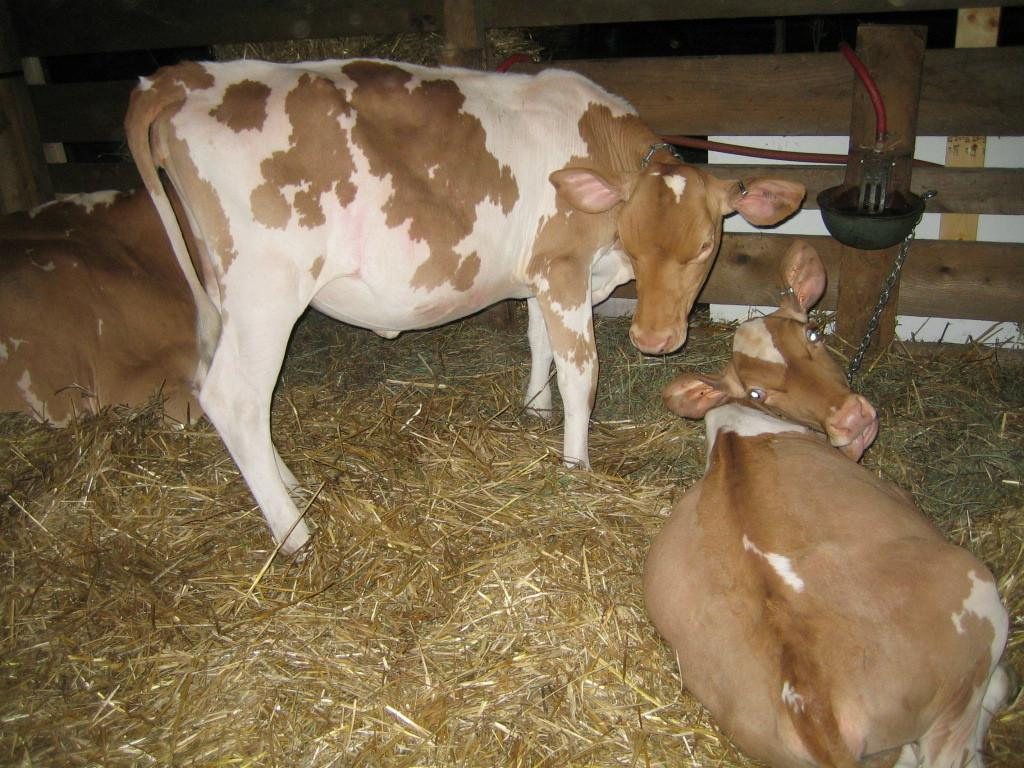What type of animals can be seen on the grass in the image? There are cows on the grass in the image. What type of barrier is present in the image? There is a wooden fence in the image. What type of container is visible in the image? There is a bowl in the image. What type of object is present in the image that is typically used for connecting or securing things? There is a chain in the image. What type of objects are present in the image that are typically used for transporting fluids? There are pipes in the image. How many friends are sitting on the sink in the image? There is no sink present in the image, and therefore no friends can be seen sitting on it. What type of knowledge can be gained from the image? The image does not convey any specific knowledge or information beyond what is already described in the facts provided. 